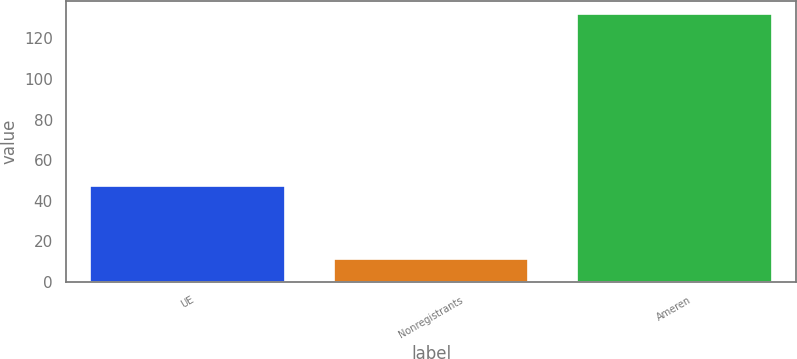Convert chart to OTSL. <chart><loc_0><loc_0><loc_500><loc_500><bar_chart><fcel>UE<fcel>Nonregistrants<fcel>Ameren<nl><fcel>47<fcel>11<fcel>132<nl></chart> 